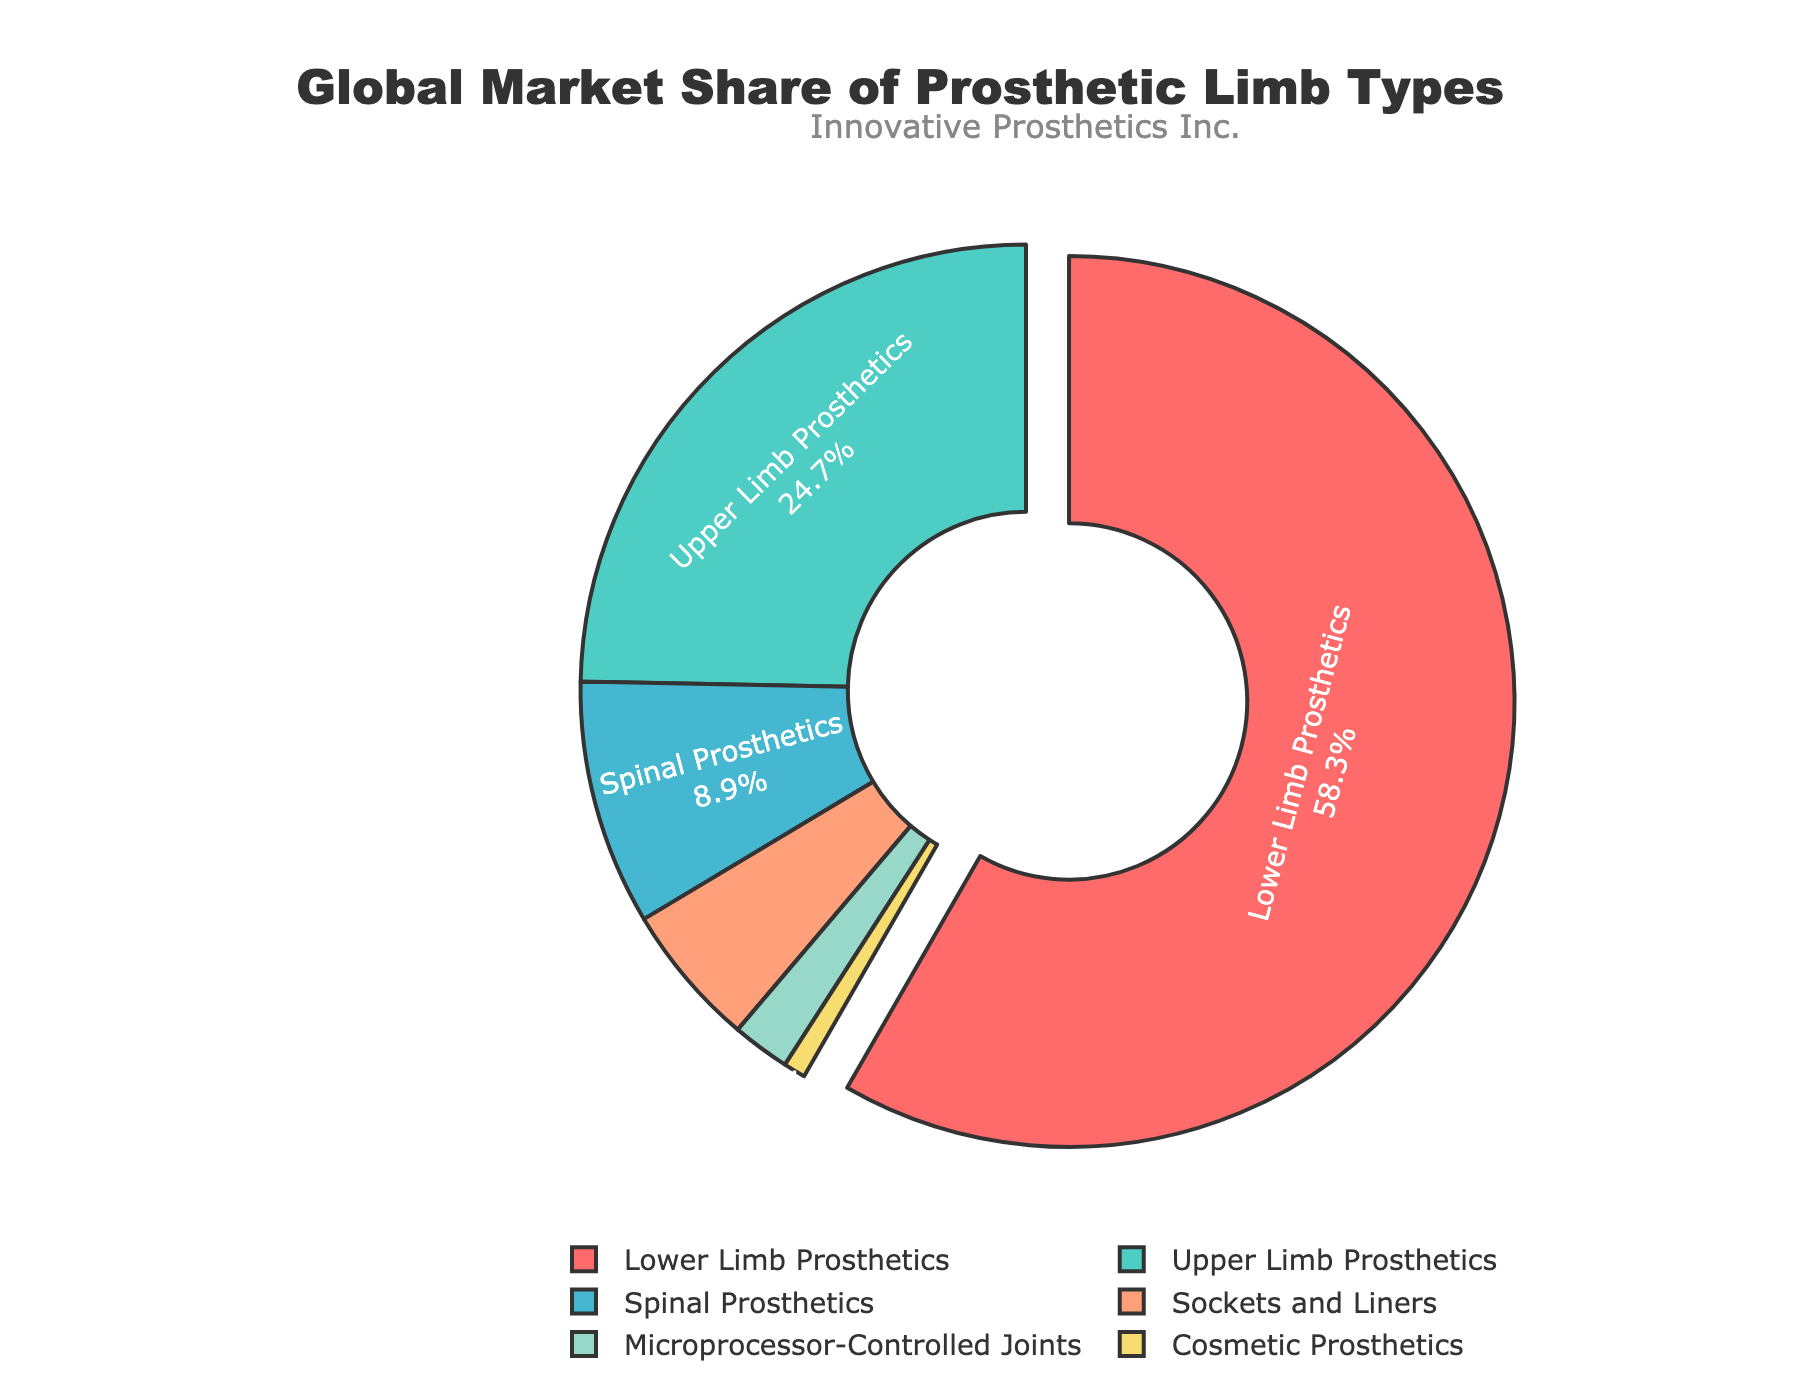What is the global market share of lower limb prosthetics? Lower limb prosthetics has a market share indicated by the largest slice in the pie chart.
Answer: 58.3% Which type of prosthetic limb has the smallest market share? The pie chart shows that cosmetic prosthetics has the smallest slice.
Answer: Cosmetic Prosthetics How much greater is the market share of lower limb prosthetics compared to upper limb prosthetics? Lower limb prosthetics has a market share of 58.3%, while upper limb prosthetics is 24.7%. Hence the difference is 58.3% - 24.7%.
Answer: 33.6% What is the combined market share of spinal prosthetics and microprocessor-controlled joints? Spinal prosthetics have a market share of 8.9%, and microprocessor-controlled joints have 2.1%. Adding them gives 8.9% + 2.1%.
Answer: 11% Which prosthetic limb types make up less than 10% of the market share individually? The chart shows that every segment with a slice less than that of spinal prosthetics (8.9%) which includes sockets and liners, microprocessor-controlled joints, and cosmetic prosthetics.
Answer: Sockets and Liners, Microprocessor-Controlled Joints, Cosmetic Prosthetics What color represents the upper limb prosthetics in the pie chart? The segment for upper limb prosthetics is visually marked with the color cyan blue (#4ECDC4).
Answer: Cyan (Aquamarine) How much more market share do sockets and liners have than microprocessor-controlled joints? The market share for sockets and liners is 5.2% while for microprocessor-controlled joints it is 2.1%. The difference is 5.2% - 2.1%.
Answer: 3.1% Which prosthetic limb type stands out with a slice pulled away from the center, and what is its market share? The largest slice representing lower limb prosthetics is visually distinguishable as it is pulled away from the pie chart center.
Answer: Lower Limb Prosthetics, 58.3% If we add the market shares of lower limb prosthetics, upper limb prosthetics, and sockets and liners, what do we get? Lower limb prosthetics has 58.3%, upper limb prosthetics 24.7%, and sockets and liners 5.2%. Adding them together gives 58.3% + 24.7% + 5.2%.
Answer: 88.2% What is the visible annotation text on the chart? The chart has an annotation near the top with the company's name.
Answer: Innovative Prosthetics Inc 